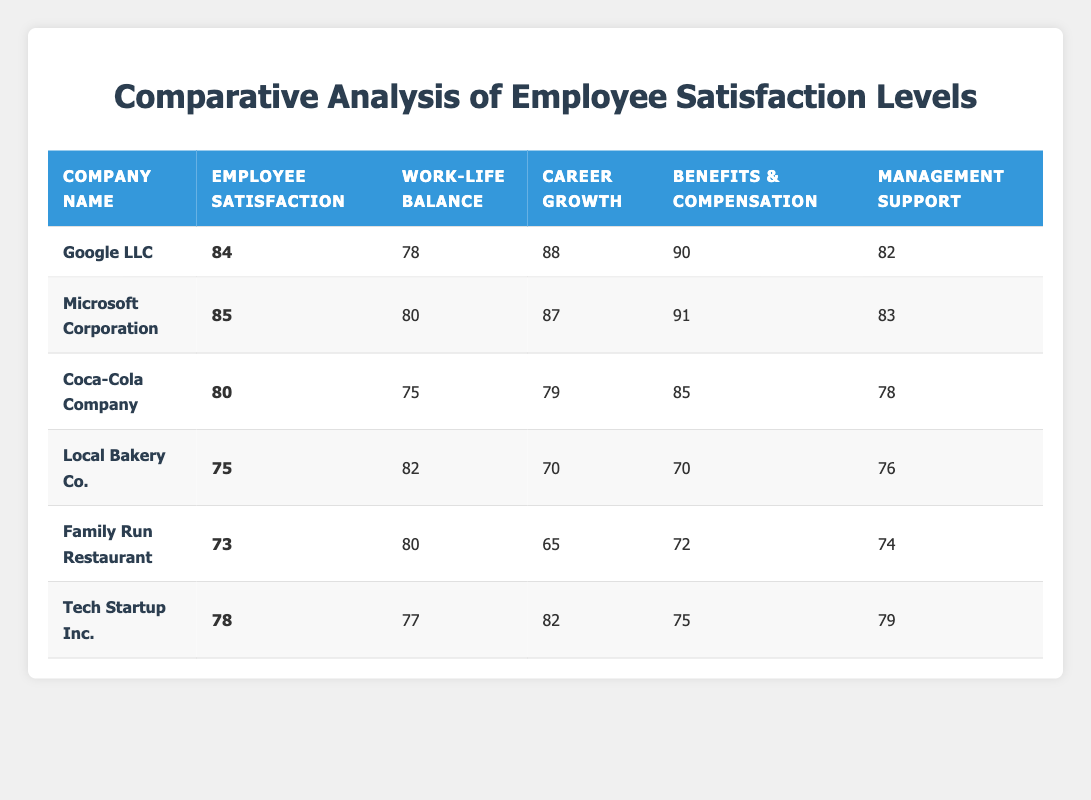What is the employee satisfaction score for Microsoft Corporation? The employee satisfaction score for Microsoft Corporation is directly listed in the table under the corresponding column. The score is indicated to be 85.
Answer: 85 Which company has the highest benefits and compensation score? The benefits and compensation scores are provided for all companies in the table. When comparing the scores, Google LLC has the highest score at 90.
Answer: Google LLC What is the average work-life balance score of local businesses? The work-life balance scores for local businesses (Local Bakery Co., Family Run Restaurant, Tech Startup Inc.) are 82, 80, and 77 respectively. The sum is 82 + 80 + 77 = 239, and there are 3 businesses, so the average is 239 / 3 = 79.67.
Answer: 79.67 Is the career growth opportunities score of Coca-Cola Company higher than that of Local Bakery Co.? The career growth opportunities score for Coca-Cola Company is 79, while for Local Bakery Co., it is 70. Since 79 is greater than 70, the statement is true.
Answer: Yes What is the total employee satisfaction score for all multinational corporations listed? The employee satisfaction scores for the multinational corporations are as follows: Google LLC (84), Microsoft Corporation (85), and Coca-Cola Company (80). The total is 84 + 85 + 80 = 249.
Answer: 249 What is the difference in management support scores between the highest and lowest? The management support scores are 83 for Microsoft Corporation (highest) and 74 for Family Run Restaurant (lowest). The difference is 83 - 74 = 9.
Answer: 9 Which company has the lowest overall employee satisfaction score, and what is that score? The lowest employee satisfaction score among all companies listed in the table is for Family Run Restaurant, which has a score of 73.
Answer: Family Run Restaurant, 73 How many companies out of the total have an employee satisfaction score above 80? The employee satisfaction scores above 80 are from Google LLC (84), Microsoft Corporation (85), and Coca-Cola Company (80). Thus, out of the total six companies, three have scores above 80.
Answer: 3 What percentage of local businesses scored below 75 in employee satisfaction? The local businesses are Local Bakery Co. (75), Family Run Restaurant (73), and Tech Startup Inc. (78). Out of these, Family Run Restaurant (73) scored below 75, which is 1 out of 3. Thus, the percentage is (1/3) * 100 = 33.33%.
Answer: 33.33% 